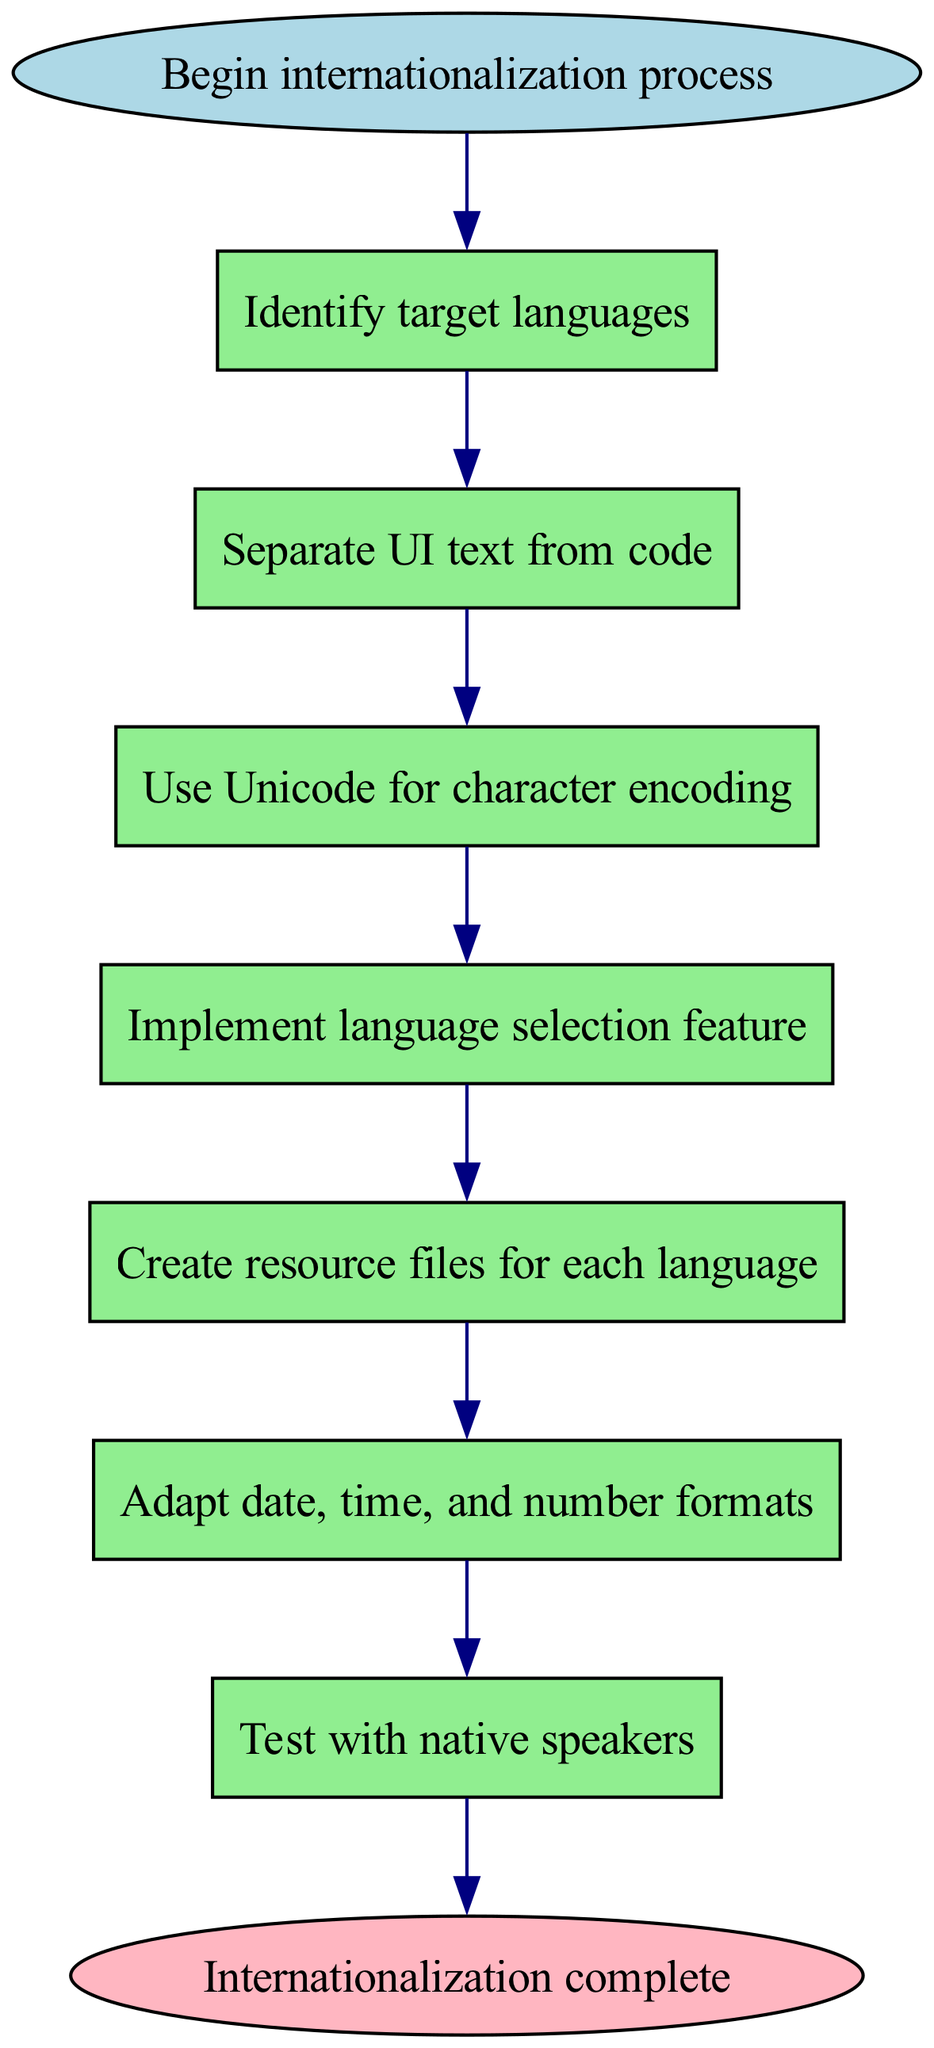What is the first step in the internationalization process? The first step, according to the diagram, is labeled as "Identify target languages." It's the first node that follows the start node.
Answer: Identify target languages How many steps are there before reaching the end? The diagram outlines a total of 7 steps before reaching the end node. Each step is a process that leads to the next until the last one, which directs to the end.
Answer: 7 Which step comes after separating UI text from code? The step that follows "Separate UI text from code" is "Use Unicode for character encoding." This is the next node connected directly after the second one in the flow.
Answer: Use Unicode for character encoding What feature should be implemented after using Unicode? The feature to be implemented after using Unicode is the "Implement language selection feature." It follows the step that discusses character encoding in the sequence.
Answer: Implement language selection feature How does the process conclude? The process concludes with the step labeled "Internationalization complete" which is connected to the last step called "Test with native speakers." It signifies the end of the internationalization process.
Answer: Internationalization complete Which step involves creating resource files? The step that involves creating resource files is "Create resource files for each language." It is positioned fifth in the sequential flow of the diagram.
Answer: Create resource files for each language What type of formatting is adapted before testing? The diagram specifies that "Adapt date, time, and number formats" is the formatting that should be adapted prior to testing with native speakers, making it a critical step for ensuring proper localization.
Answer: Adapt date, time, and number formats Why must native speakers be involved in testing? The reason for involving native speakers in testing is to ensure that the software application is accurately translated and culturally relevant. This is a common practice in internationalization for validating the final product's usability for different language users.
Answer: To ensure accuracy and cultural relevance 